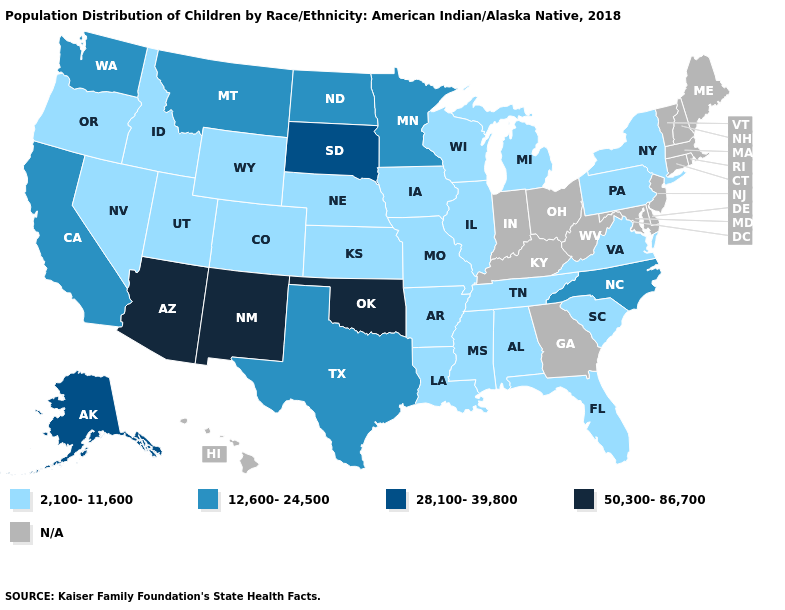Name the states that have a value in the range 2,100-11,600?
Concise answer only. Alabama, Arkansas, Colorado, Florida, Idaho, Illinois, Iowa, Kansas, Louisiana, Michigan, Mississippi, Missouri, Nebraska, Nevada, New York, Oregon, Pennsylvania, South Carolina, Tennessee, Utah, Virginia, Wisconsin, Wyoming. What is the value of South Dakota?
Write a very short answer. 28,100-39,800. Name the states that have a value in the range 28,100-39,800?
Keep it brief. Alaska, South Dakota. Among the states that border South Dakota , which have the lowest value?
Answer briefly. Iowa, Nebraska, Wyoming. What is the value of Minnesota?
Concise answer only. 12,600-24,500. Which states hav the highest value in the MidWest?
Answer briefly. South Dakota. Which states have the lowest value in the West?
Give a very brief answer. Colorado, Idaho, Nevada, Oregon, Utah, Wyoming. Name the states that have a value in the range 28,100-39,800?
Be succinct. Alaska, South Dakota. Name the states that have a value in the range 50,300-86,700?
Answer briefly. Arizona, New Mexico, Oklahoma. Among the states that border Nebraska , does Kansas have the lowest value?
Quick response, please. Yes. Does the map have missing data?
Short answer required. Yes. How many symbols are there in the legend?
Answer briefly. 5. Name the states that have a value in the range 2,100-11,600?
Short answer required. Alabama, Arkansas, Colorado, Florida, Idaho, Illinois, Iowa, Kansas, Louisiana, Michigan, Mississippi, Missouri, Nebraska, Nevada, New York, Oregon, Pennsylvania, South Carolina, Tennessee, Utah, Virginia, Wisconsin, Wyoming. 